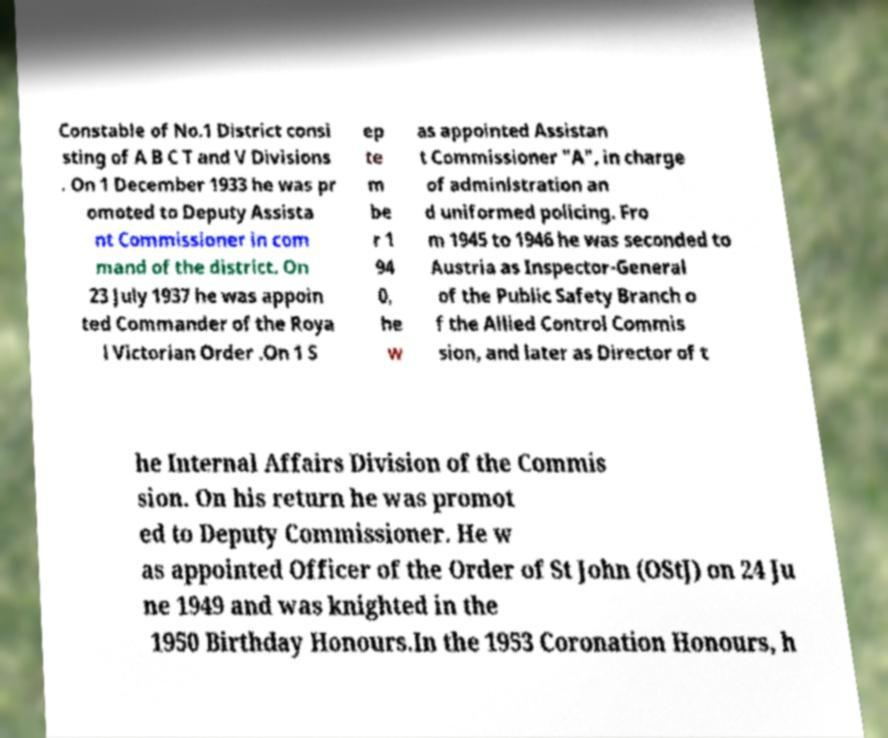I need the written content from this picture converted into text. Can you do that? Constable of No.1 District consi sting of A B C T and V Divisions . On 1 December 1933 he was pr omoted to Deputy Assista nt Commissioner in com mand of the district. On 23 July 1937 he was appoin ted Commander of the Roya l Victorian Order .On 1 S ep te m be r 1 94 0, he w as appointed Assistan t Commissioner "A", in charge of administration an d uniformed policing. Fro m 1945 to 1946 he was seconded to Austria as Inspector-General of the Public Safety Branch o f the Allied Control Commis sion, and later as Director of t he Internal Affairs Division of the Commis sion. On his return he was promot ed to Deputy Commissioner. He w as appointed Officer of the Order of St John (OStJ) on 24 Ju ne 1949 and was knighted in the 1950 Birthday Honours.In the 1953 Coronation Honours, h 